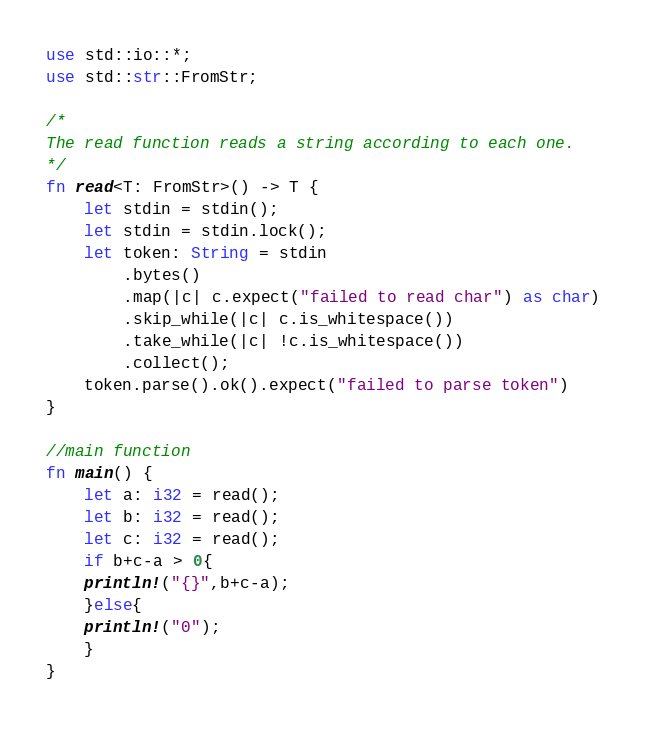Convert code to text. <code><loc_0><loc_0><loc_500><loc_500><_Rust_>use std::io::*;
use std::str::FromStr;
 
/* 
The read function reads a string according to each one. 
*/
fn read<T: FromStr>() -> T {
    let stdin = stdin();
    let stdin = stdin.lock();
    let token: String = stdin
        .bytes()
        .map(|c| c.expect("failed to read char") as char) 
        .skip_while(|c| c.is_whitespace())
        .take_while(|c| !c.is_whitespace())
        .collect();
    token.parse().ok().expect("failed to parse token")
}

//main function
fn main() {
    let a: i32 = read();
    let b: i32 = read();
    let c: i32 = read();
    if b+c-a > 0{
	println!("{}",b+c-a);
    }else{
	println!("0");
    }
}
</code> 